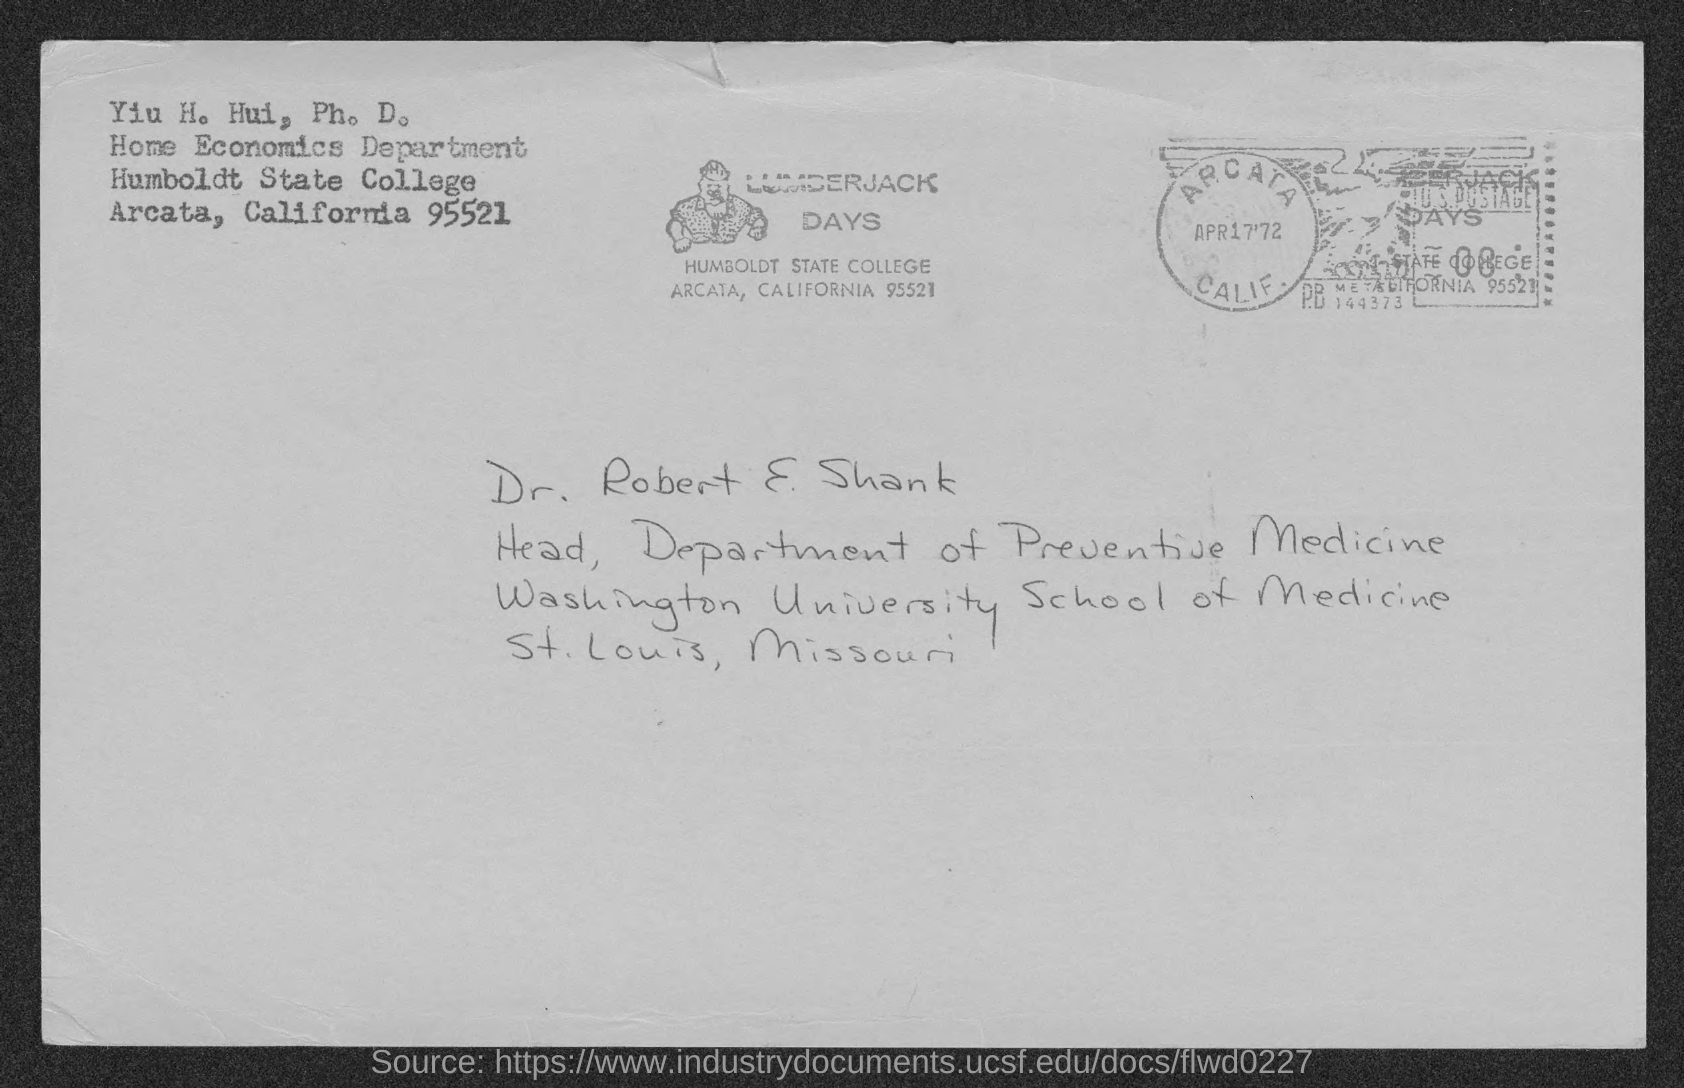Point out several critical features in this image. Humboldt State College is located in Arcat The university mentioned is Washington University School of Medicine. Dr. Robert E Shank is the Head of the Department of Preventive Medicine. Humboldt State College is the name of a college. 